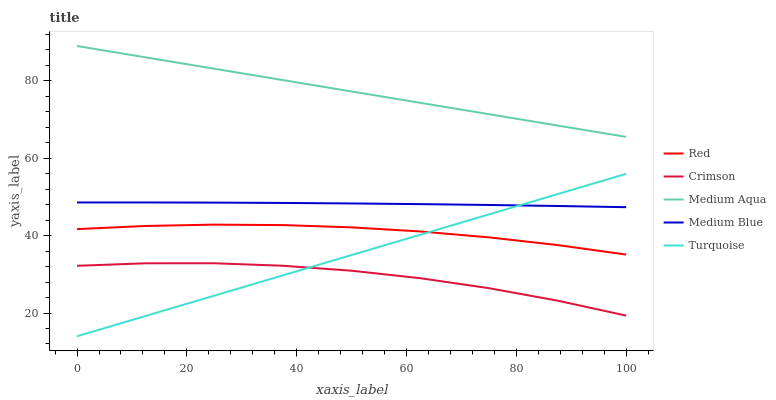Does Crimson have the minimum area under the curve?
Answer yes or no. Yes. Does Medium Aqua have the maximum area under the curve?
Answer yes or no. Yes. Does Medium Blue have the minimum area under the curve?
Answer yes or no. No. Does Medium Blue have the maximum area under the curve?
Answer yes or no. No. Is Turquoise the smoothest?
Answer yes or no. Yes. Is Crimson the roughest?
Answer yes or no. Yes. Is Medium Blue the smoothest?
Answer yes or no. No. Is Medium Blue the roughest?
Answer yes or no. No. Does Turquoise have the lowest value?
Answer yes or no. Yes. Does Medium Blue have the lowest value?
Answer yes or no. No. Does Medium Aqua have the highest value?
Answer yes or no. Yes. Does Medium Blue have the highest value?
Answer yes or no. No. Is Crimson less than Red?
Answer yes or no. Yes. Is Medium Aqua greater than Medium Blue?
Answer yes or no. Yes. Does Turquoise intersect Medium Blue?
Answer yes or no. Yes. Is Turquoise less than Medium Blue?
Answer yes or no. No. Is Turquoise greater than Medium Blue?
Answer yes or no. No. Does Crimson intersect Red?
Answer yes or no. No. 